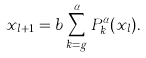Convert formula to latex. <formula><loc_0><loc_0><loc_500><loc_500>x _ { l + 1 } = b \sum _ { k = g } ^ { \alpha } P ^ { \alpha } _ { k } ( x _ { l } ) .</formula> 